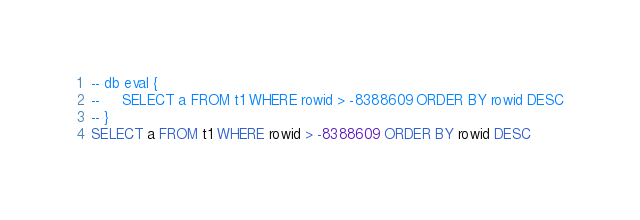Convert code to text. <code><loc_0><loc_0><loc_500><loc_500><_SQL_>-- db eval {
--     SELECT a FROM t1 WHERE rowid > -8388609 ORDER BY rowid DESC
-- }
SELECT a FROM t1 WHERE rowid > -8388609 ORDER BY rowid DESC</code> 